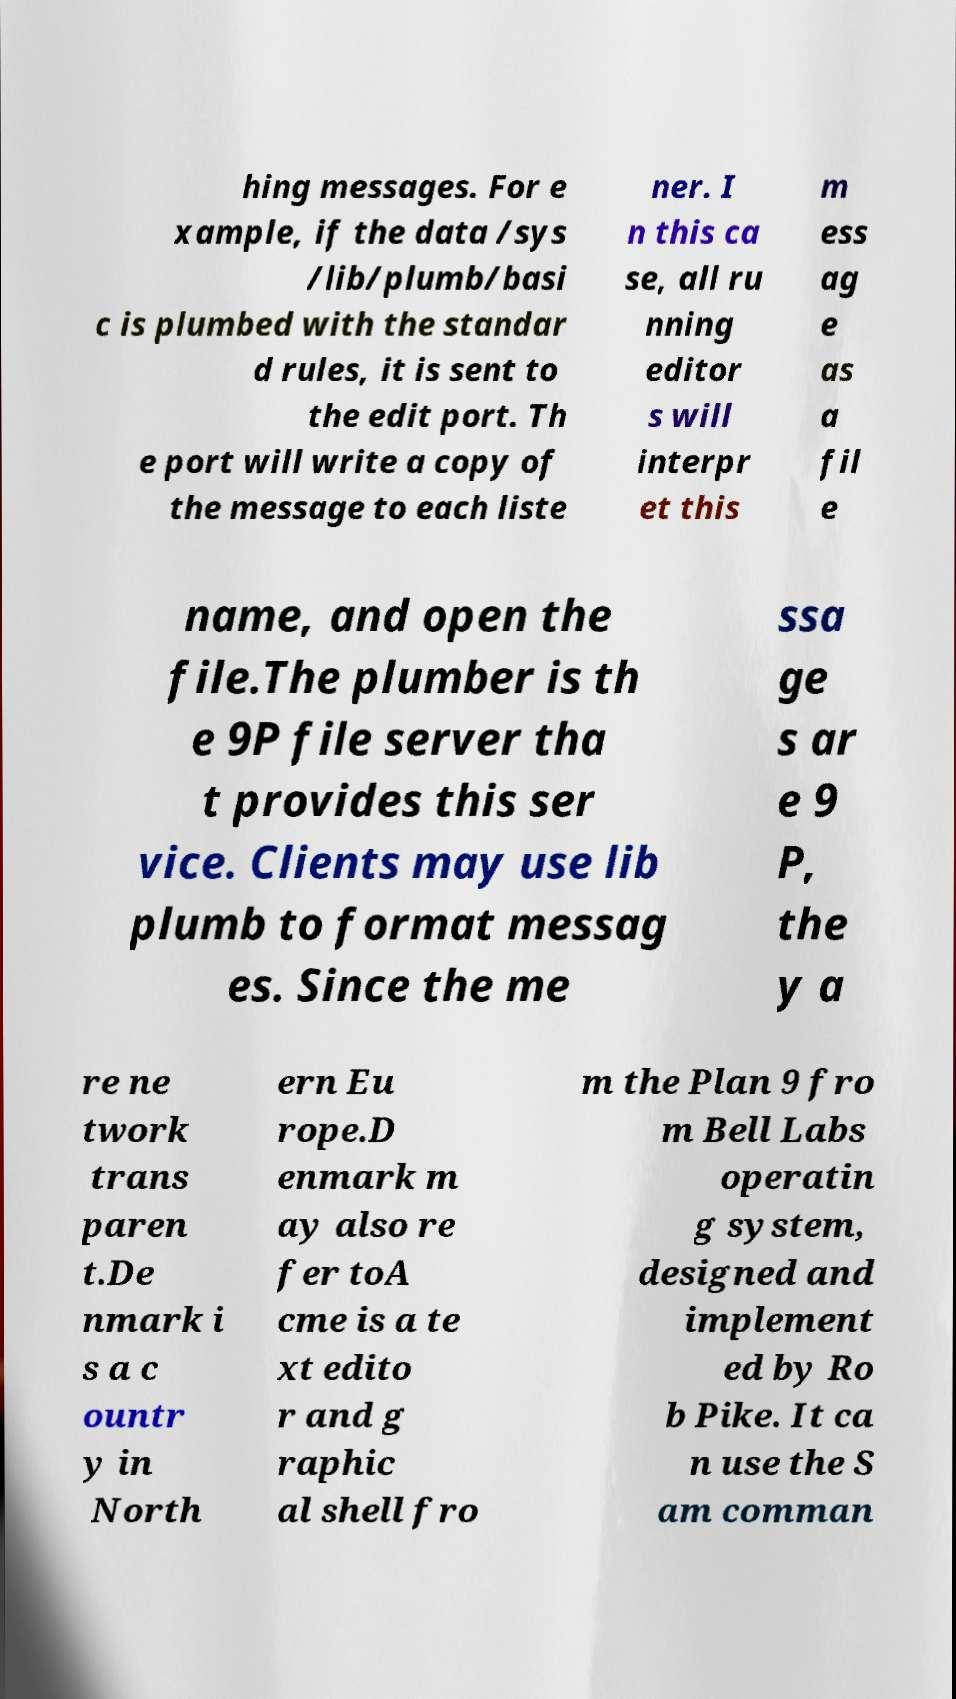There's text embedded in this image that I need extracted. Can you transcribe it verbatim? hing messages. For e xample, if the data /sys /lib/plumb/basi c is plumbed with the standar d rules, it is sent to the edit port. Th e port will write a copy of the message to each liste ner. I n this ca se, all ru nning editor s will interpr et this m ess ag e as a fil e name, and open the file.The plumber is th e 9P file server tha t provides this ser vice. Clients may use lib plumb to format messag es. Since the me ssa ge s ar e 9 P, the y a re ne twork trans paren t.De nmark i s a c ountr y in North ern Eu rope.D enmark m ay also re fer toA cme is a te xt edito r and g raphic al shell fro m the Plan 9 fro m Bell Labs operatin g system, designed and implement ed by Ro b Pike. It ca n use the S am comman 